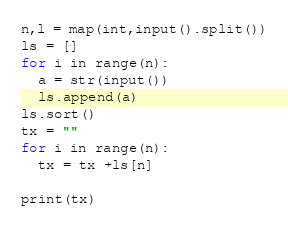Convert code to text. <code><loc_0><loc_0><loc_500><loc_500><_Python_>n,l = map(int,input().split())
ls = []
for i in range(n):
  a = str(input())
  ls.append(a)
ls.sort()
tx = ""
for i in range(n):
  tx = tx +ls[n]

print(tx)</code> 